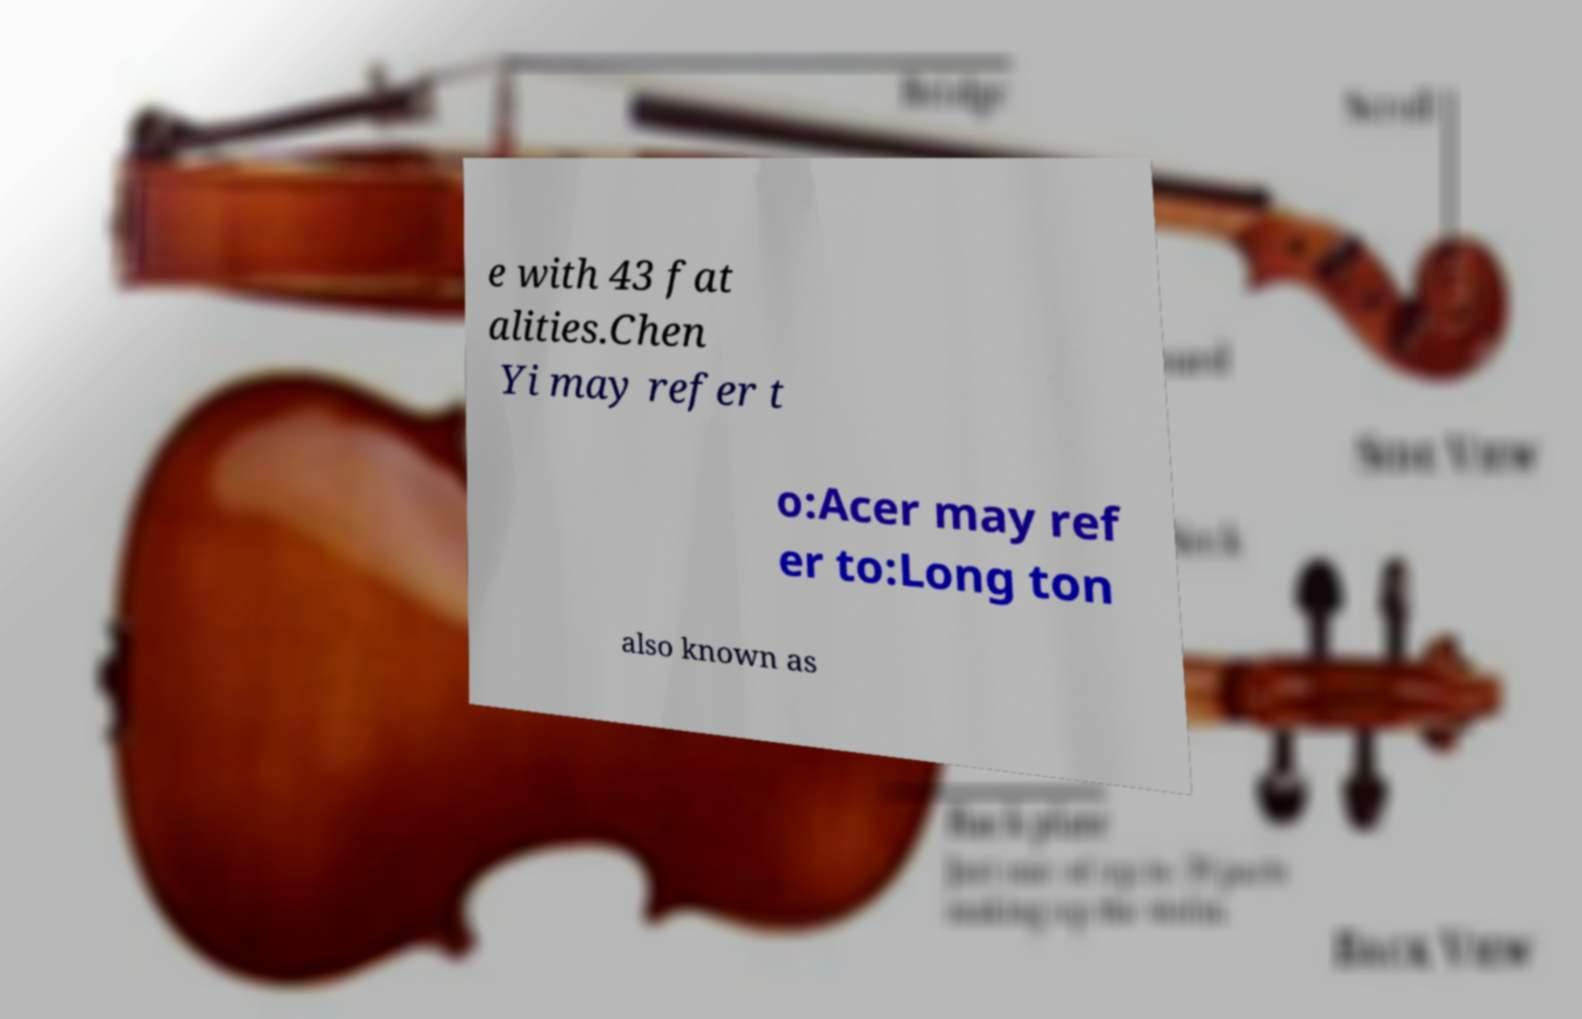What messages or text are displayed in this image? I need them in a readable, typed format. e with 43 fat alities.Chen Yi may refer t o:Acer may ref er to:Long ton also known as 